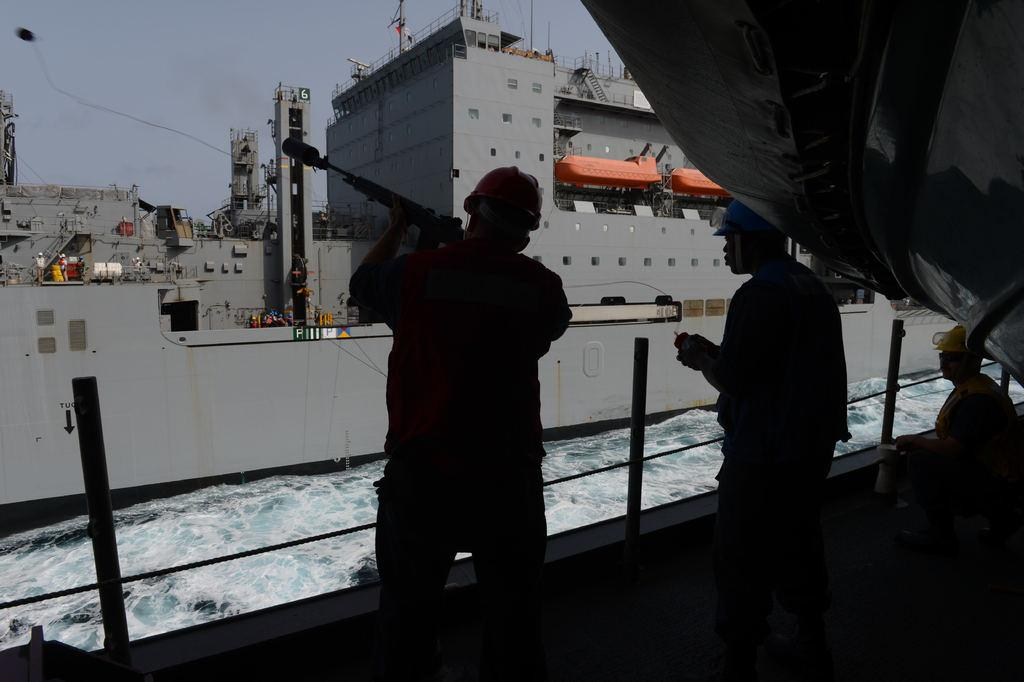Who is present in the image? There are people in the image. What are the people doing in the image? The people are on ships. What are some people wearing in the image? Some people are wearing helmets. What are some people holding in the image? Some people are holding objects. What can be seen at the top of the image? There is sky visible at the top of the image. What can be seen at the bottom of the image? There is water visible at the bottom of the image. What type of art can be seen on the ships in the image? There is no art visible on the ships in the image. What need do the people on the ships have in the image? The image does not provide information about any specific needs the people may have. 